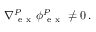<formula> <loc_0><loc_0><loc_500><loc_500>_ { e x } ^ { P } \boldsymbol _ { e x } ^ { P } \neq 0 \, .</formula> 